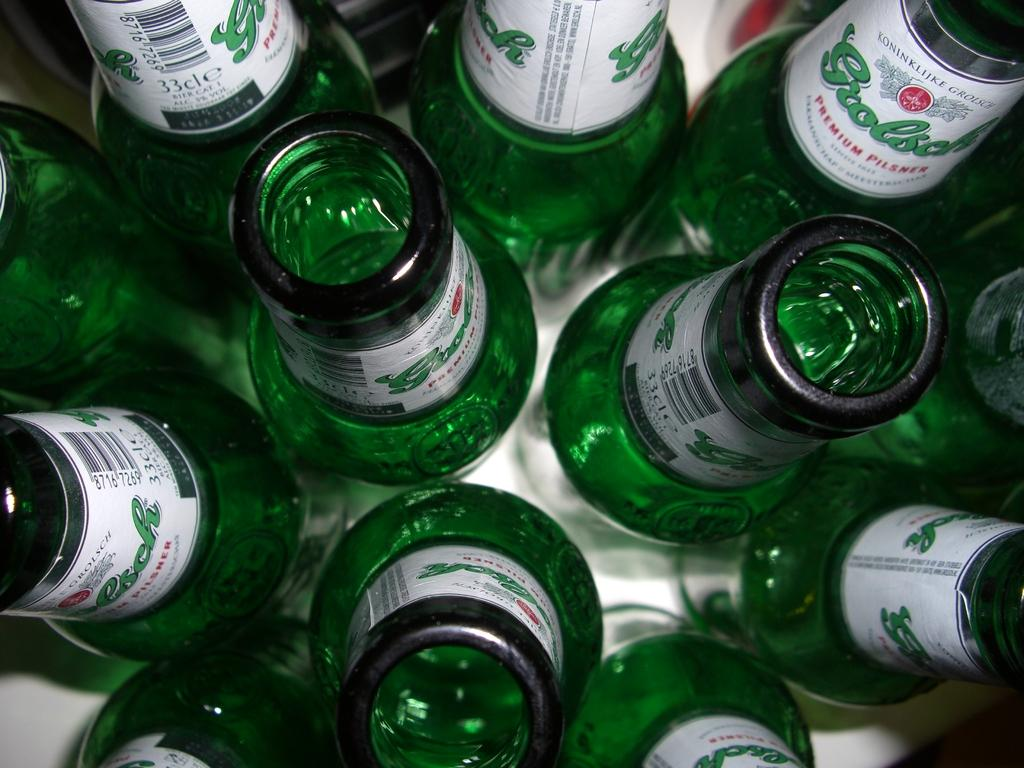What objects are present in the image in a group? There is a group of green bottles in the image. What is the color of the table on which the bottles are placed? The table is white in color. Are there any additional decorations or markings on the bottles? Yes, there are stickers on the bottles. What is the color of the stickers? The stickers are in white color. How many pigs are visible on the roof in the image? There are no pigs or roof present in the image; it features a group of green bottles on a white table with white stickers. 